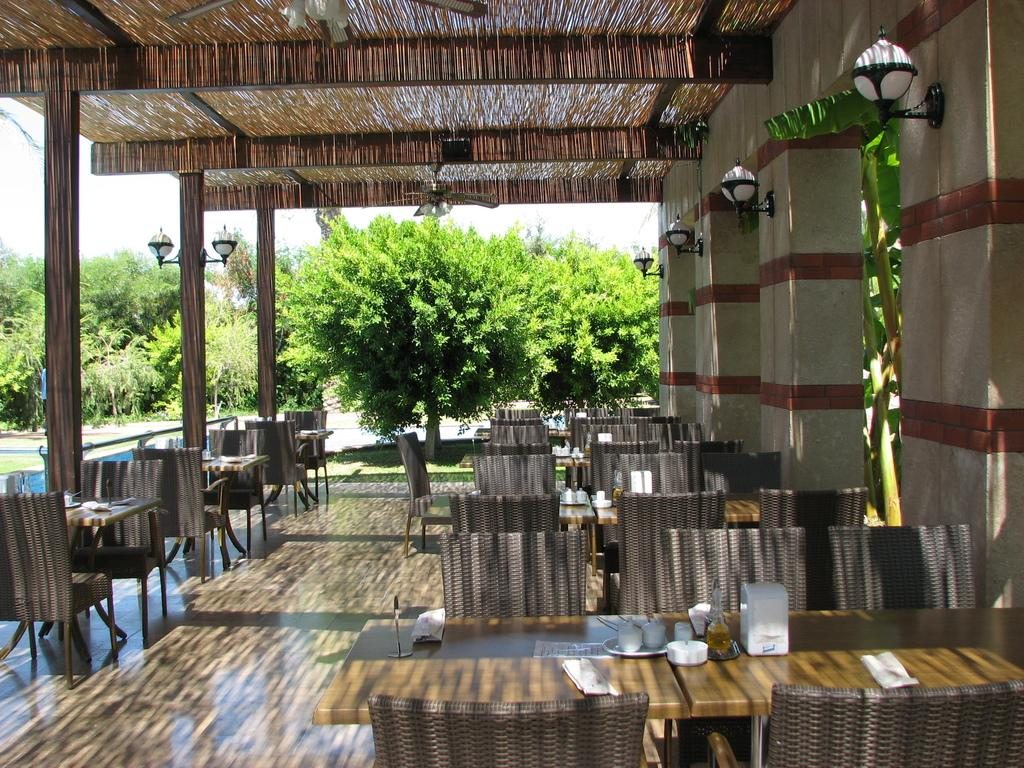What type of furniture is present in the image? There are chairs and tables in the image. What type of lighting is present in the image? There are metal lights in the image. What type of structural support is present in the image? There are pillars in the image. What type of cooling device is present in the image? There are fans in the image. What type of vegetation is present in the image? There are trees in the image. What objects can be seen on the table in the image? There are objects placed on the table in the image. How many horses are present in the image? There are no horses present in the image. What type of tin object can be seen in the image? There is no tin object present in the image. 